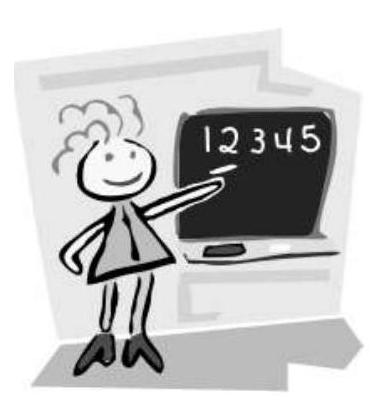What educational assumptions can we make based on the presentation style shown in the image? The presentation style, with its simplicity and clarity, suggests it's geared towards young learners, possibly in a primary school. Such visuals are effective for engaging children and helping them grasp foundational concepts in a visually appealing and straightforward manner. Is there a specific teaching method that could be associated with this style of presentation? This style of presentation might be associated with the direct instruction method, where teachers explicitly teach specific skills or concepts in a step-by-step approach, using clear and concise explanations. It emphasizes clarity and immediate feedback, which is visible in the image. 